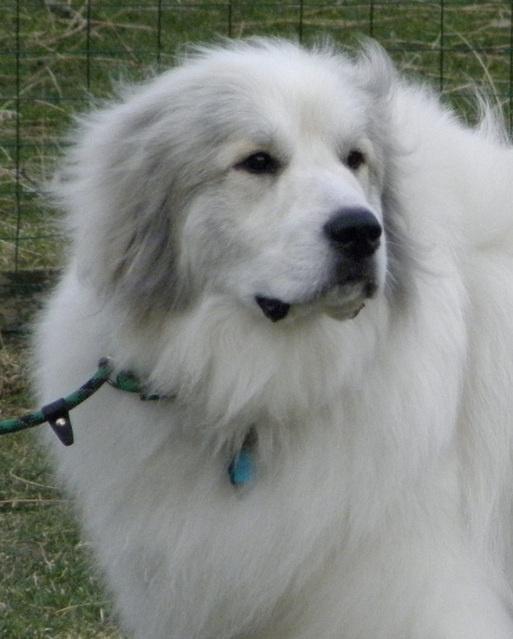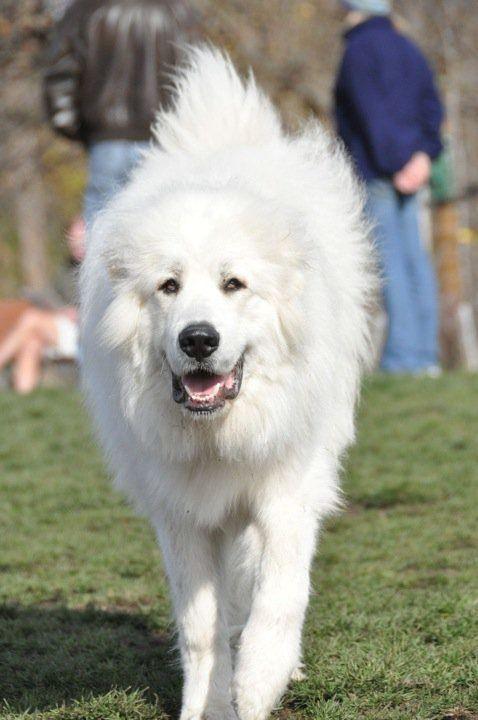The first image is the image on the left, the second image is the image on the right. Evaluate the accuracy of this statement regarding the images: "The left photo is of a puppy.". Is it true? Answer yes or no. No. 